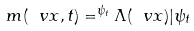<formula> <loc_0><loc_0><loc_500><loc_500>m ( \ v x , t ) = ^ { \psi _ { t } } { \Lambda ( \ v x ) | \psi _ { t } }</formula> 